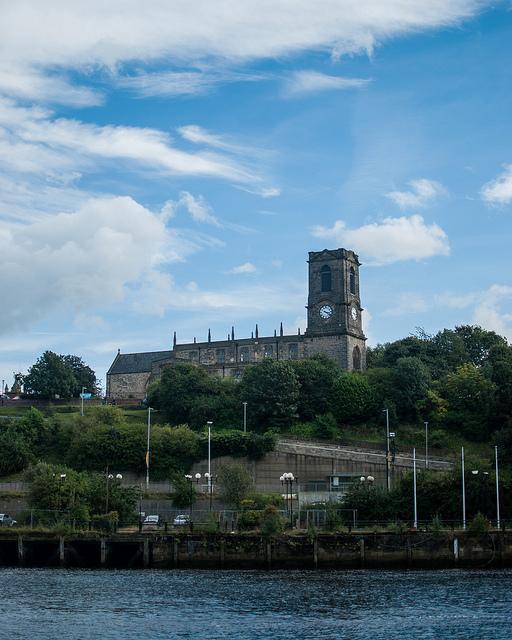How many steeples are there?
Give a very brief answer. 1. How many buildings are there?
Give a very brief answer. 1. How many zebras are there?
Give a very brief answer. 0. 